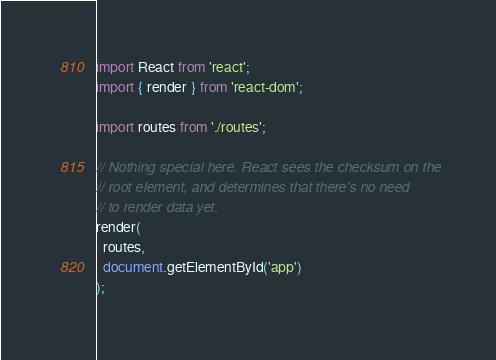Convert code to text. <code><loc_0><loc_0><loc_500><loc_500><_JavaScript_>import React from 'react';
import { render } from 'react-dom';

import routes from './routes';

// Nothing special here. React sees the checksum on the
// root element, and determines that there's no need
// to render data yet.
render(
  routes,
  document.getElementById('app')
);
</code> 